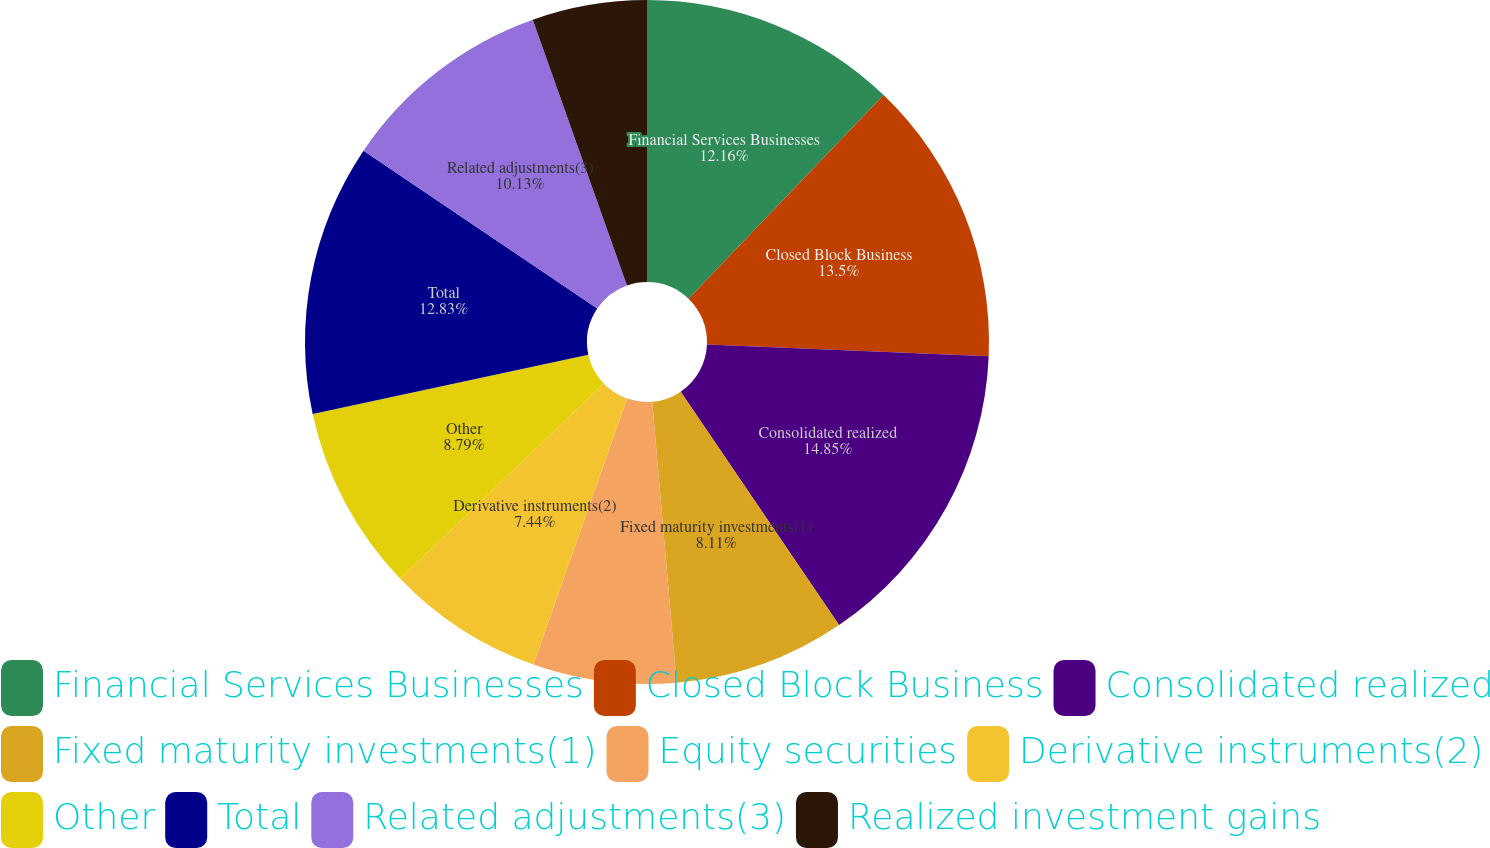Convert chart. <chart><loc_0><loc_0><loc_500><loc_500><pie_chart><fcel>Financial Services Businesses<fcel>Closed Block Business<fcel>Consolidated realized<fcel>Fixed maturity investments(1)<fcel>Equity securities<fcel>Derivative instruments(2)<fcel>Other<fcel>Total<fcel>Related adjustments(3)<fcel>Realized investment gains<nl><fcel>12.16%<fcel>13.5%<fcel>14.85%<fcel>8.11%<fcel>6.77%<fcel>7.44%<fcel>8.79%<fcel>12.83%<fcel>10.13%<fcel>5.42%<nl></chart> 